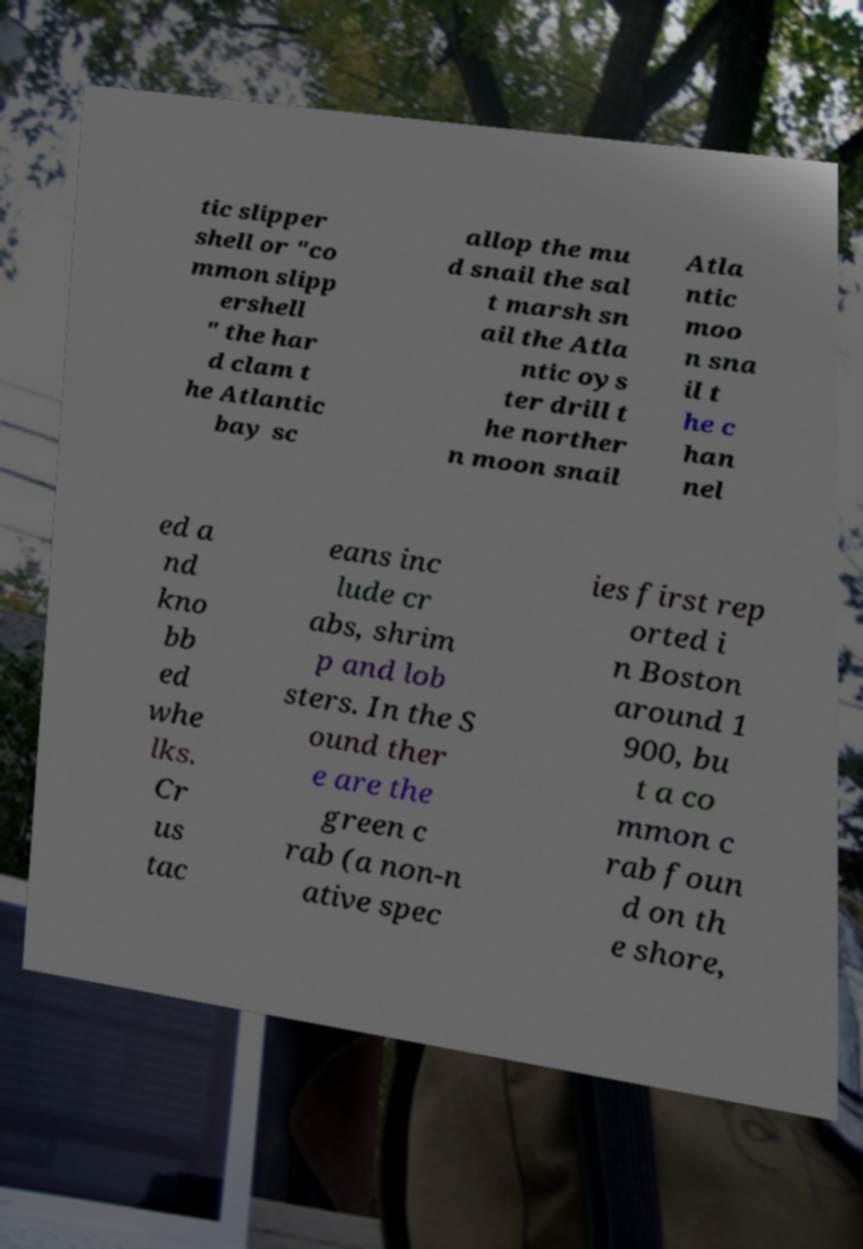Please identify and transcribe the text found in this image. tic slipper shell or "co mmon slipp ershell " the har d clam t he Atlantic bay sc allop the mu d snail the sal t marsh sn ail the Atla ntic oys ter drill t he norther n moon snail Atla ntic moo n sna il t he c han nel ed a nd kno bb ed whe lks. Cr us tac eans inc lude cr abs, shrim p and lob sters. In the S ound ther e are the green c rab (a non-n ative spec ies first rep orted i n Boston around 1 900, bu t a co mmon c rab foun d on th e shore, 